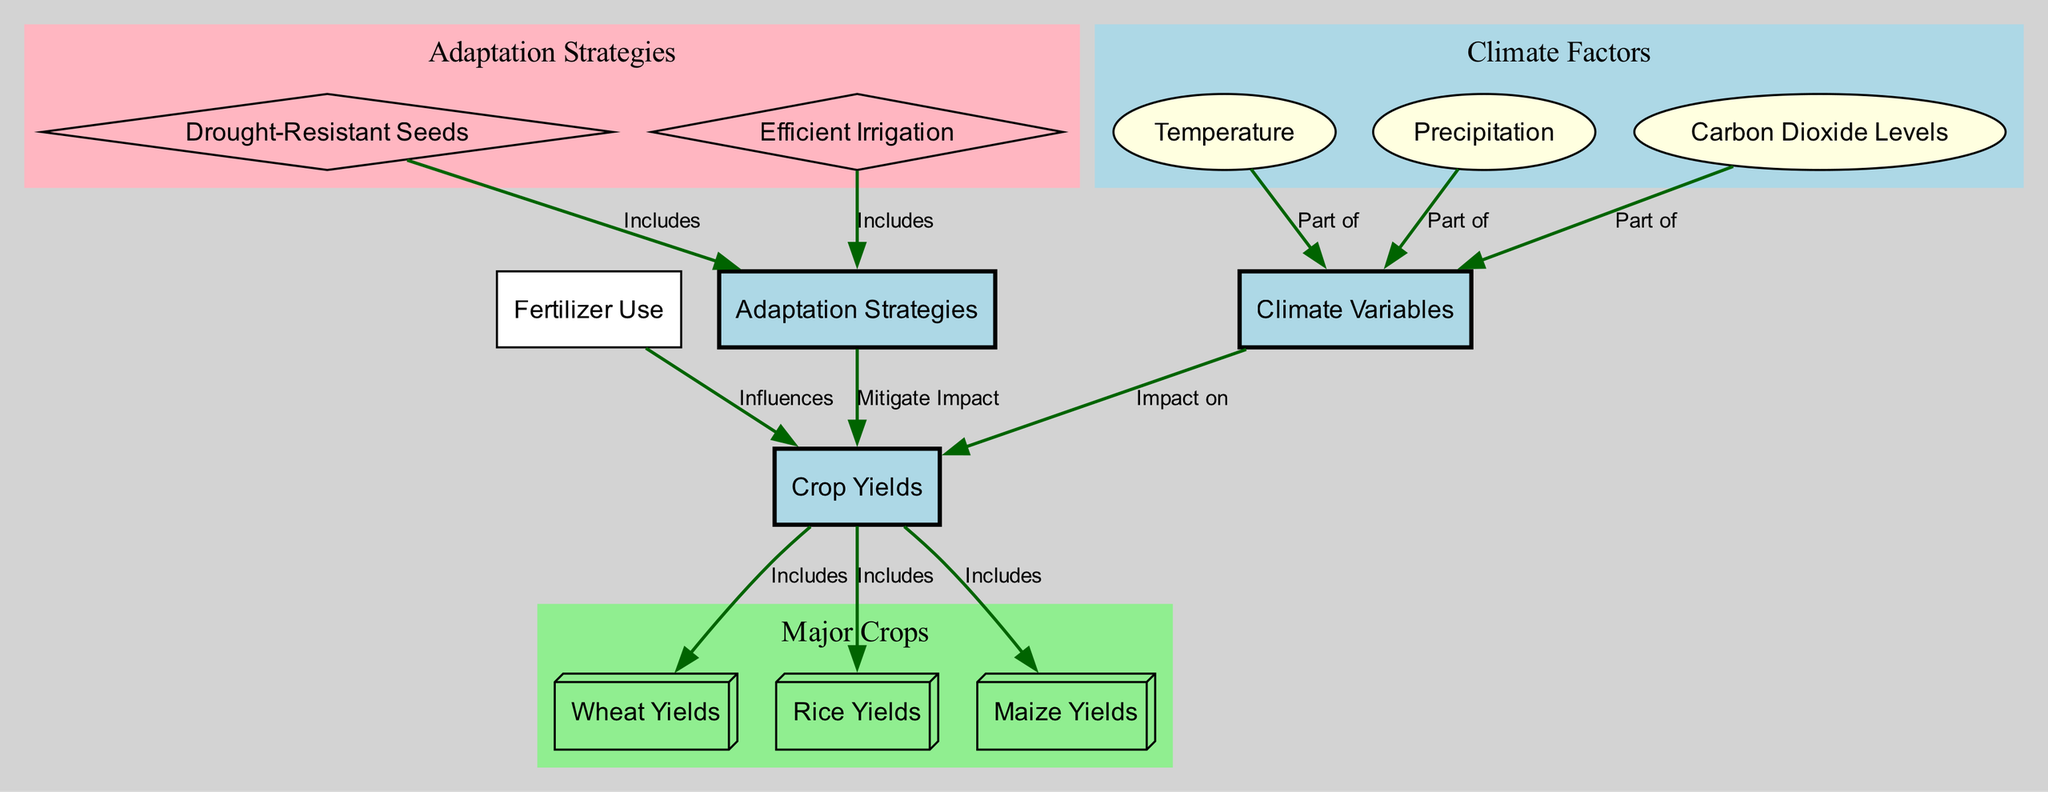What are the major crops included in crop yields? The diagram explicitly lists wheat, rice, and maize as part of crop yields. This can be identified from the edges connecting crop yields to these specific crops, indicating their inclusion.
Answer: wheat, rice, maize How many climate variables are represented? The diagram shows three distinct climate variables: temperature, precipitation, and carbon dioxide. Each of these is a separate node linked to the climate variables node, confirming their count.
Answer: 3 What strategy includes the use of drought-resistant seeds? The diagram indicates that drought-resistant seeds are part of the adaptation strategies through an edge representing this inclusion. This clearly shows their role in mitigating the impact on crop yields.
Answer: Adaptation Strategies Which climate variable impacts crop yields the most directly? The diagram illustrates that climate variables, which include temperature, precipitation, and carbon dioxide, collectively impact crop yields. However, it does not specify which one has the most impact, thus indicating that the relationship is general.
Answer: Climate Variables How does fertilizer use influence crop yields? The diagram explicitly shows that fertilizer use influences crop yields directly, as indicated by a clear edge connecting fertilizer use to crop yields. This demonstrates a supporting role of fertilizers in determining agricultural output.
Answer: Influences What two adaptation strategies are shown in the diagram? The diagram displays two adaptation strategies: drought-resistant seeds and efficient irrigation, both indicated as sub-nodes under the broader adaptation strategies node. Their presence highlights the methods to mitigate climate impacts on farming.
Answer: Drought-Resistant Seeds, Efficient Irrigation What is the role of carbon dioxide levels in relation to climate variables? The diagram defines carbon dioxide levels as a part of climate variables. This suggests that it is one of the factors that must be considered when analyzing climate impact on agriculture.
Answer: Part of Which crop yield is linked most closely with fertilizer use? The diagram shows a direct influence of fertilizer use on all crop yields, without distinguishing which crop yield benefits the most specifically. Thus, it indicates that fertilizer benefits all crops represented.
Answer: Crop Yields 